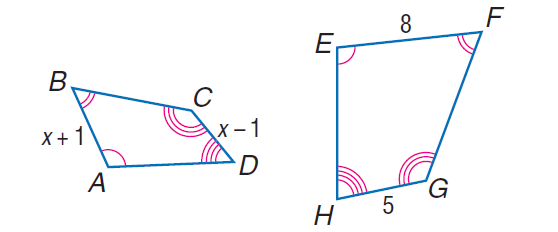Question: Each pair of polygons is similar. Find A B.
Choices:
A. 1.6
B. \frac { 16 } { 3 }
C. 6
D. 10
Answer with the letter. Answer: B Question: Each pair of polygons is similar. Find C D.
Choices:
A. 3.333
B. \frac { 10 } { 3 }
C. 4
D. 10
Answer with the letter. Answer: B 